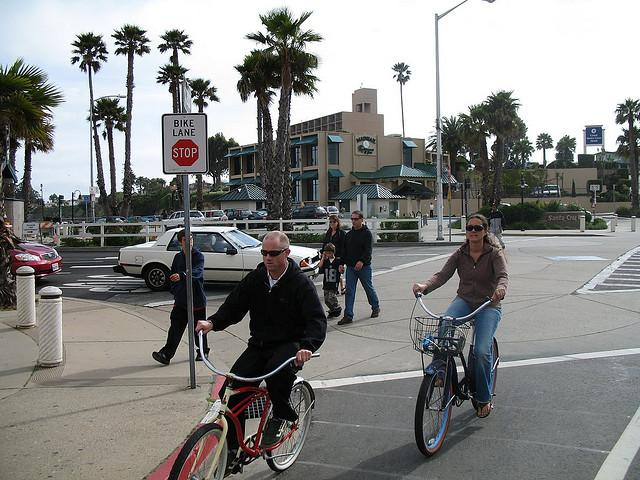What kind of sign is shown?

Choices:
A) traffic
B) name
C) brand
D) price traffic 